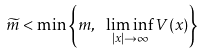Convert formula to latex. <formula><loc_0><loc_0><loc_500><loc_500>\widetilde { m } < \min \left \{ m , \ \liminf _ { | x | \to \infty } V ( x ) \right \}</formula> 